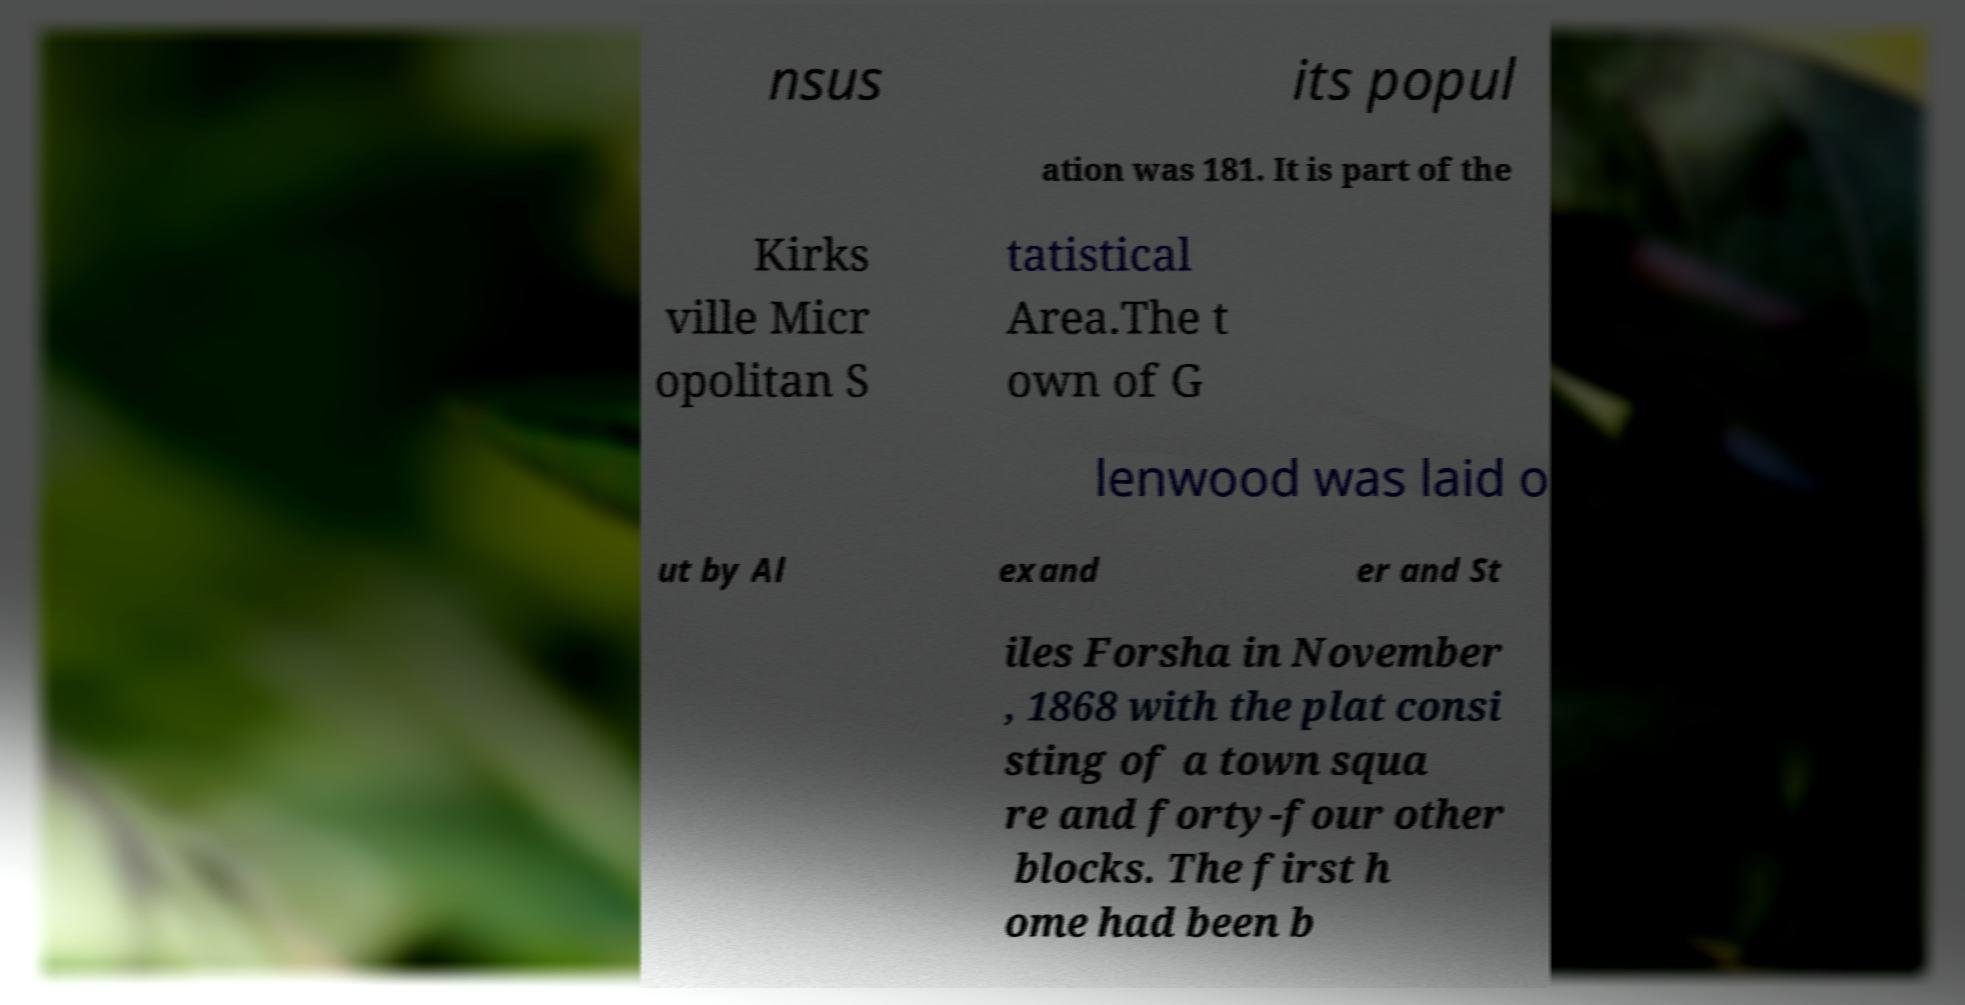Please read and relay the text visible in this image. What does it say? nsus its popul ation was 181. It is part of the Kirks ville Micr opolitan S tatistical Area.The t own of G lenwood was laid o ut by Al exand er and St iles Forsha in November , 1868 with the plat consi sting of a town squa re and forty-four other blocks. The first h ome had been b 